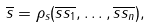Convert formula to latex. <formula><loc_0><loc_0><loc_500><loc_500>\overline { s } = \rho _ { s } ( \overline { s s _ { 1 } } , \dots , \overline { s s _ { n } } ) ,</formula> 